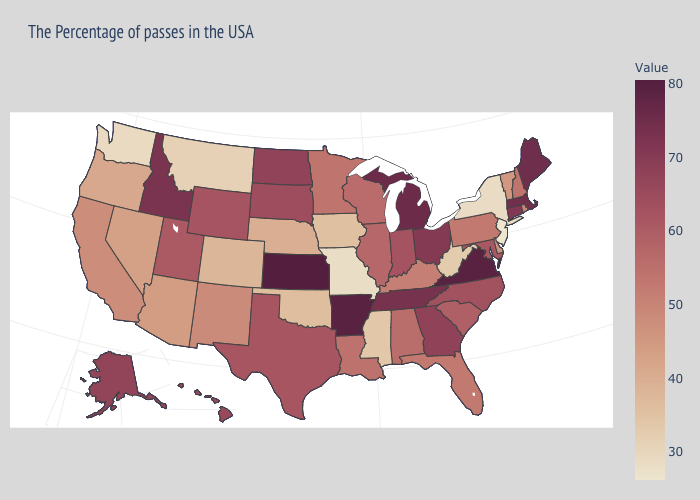Which states hav the highest value in the West?
Answer briefly. Idaho. Among the states that border New Hampshire , which have the lowest value?
Quick response, please. Vermont. Does Iowa have the lowest value in the MidWest?
Concise answer only. No. Among the states that border Massachusetts , does Vermont have the lowest value?
Quick response, please. No. Among the states that border Texas , does Arkansas have the highest value?
Concise answer only. Yes. Does Massachusetts have the highest value in the USA?
Write a very short answer. No. 